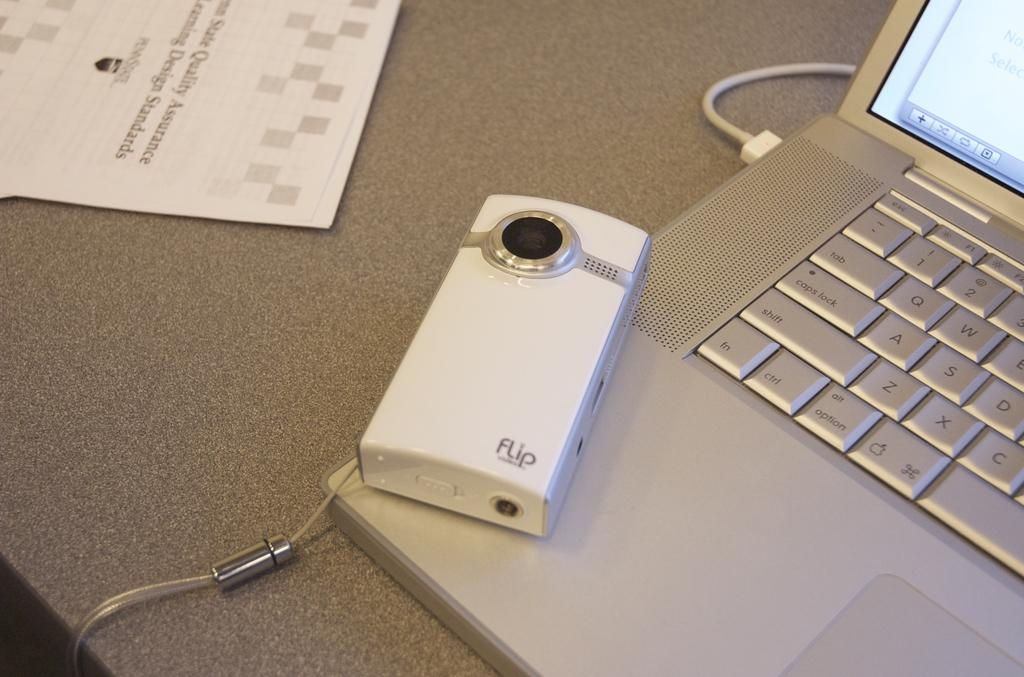<image>
Offer a succinct explanation of the picture presented. A computer sitting beside a piece of paper that says quality assurance. 